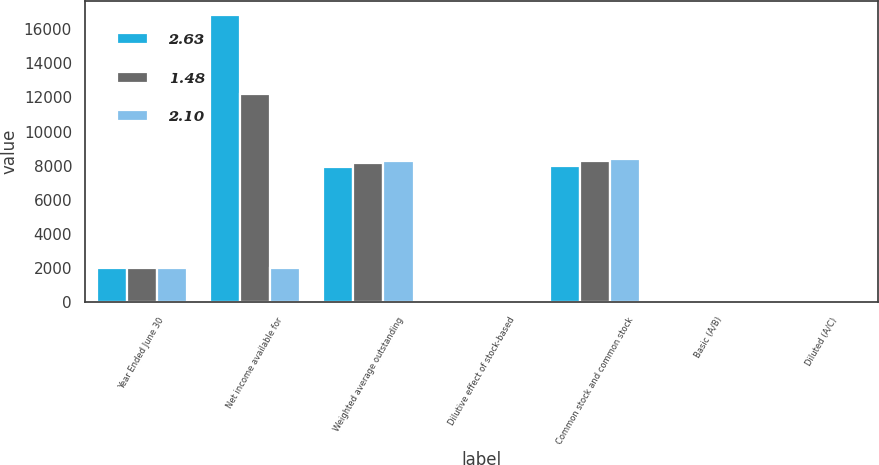<chart> <loc_0><loc_0><loc_500><loc_500><stacked_bar_chart><ecel><fcel>Year Ended June 30<fcel>Net income available for<fcel>Weighted average outstanding<fcel>Dilutive effect of stock-based<fcel>Common stock and common stock<fcel>Basic (A/B)<fcel>Diluted (A/C)<nl><fcel>2.63<fcel>2016<fcel>16798<fcel>7925<fcel>88<fcel>8013<fcel>2.12<fcel>2.1<nl><fcel>1.48<fcel>2015<fcel>12193<fcel>8177<fcel>77<fcel>8254<fcel>1.49<fcel>1.48<nl><fcel>2.1<fcel>2014<fcel>2014.5<fcel>8299<fcel>100<fcel>8399<fcel>2.66<fcel>2.63<nl></chart> 